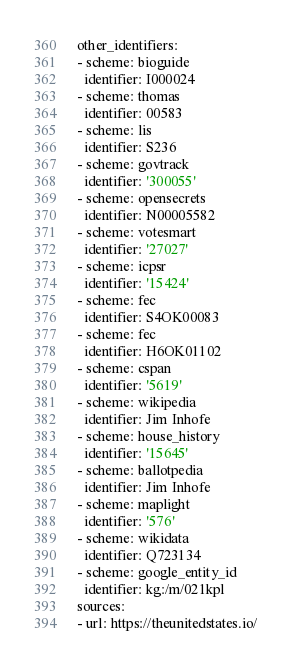<code> <loc_0><loc_0><loc_500><loc_500><_YAML_>other_identifiers:
- scheme: bioguide
  identifier: I000024
- scheme: thomas
  identifier: 00583
- scheme: lis
  identifier: S236
- scheme: govtrack
  identifier: '300055'
- scheme: opensecrets
  identifier: N00005582
- scheme: votesmart
  identifier: '27027'
- scheme: icpsr
  identifier: '15424'
- scheme: fec
  identifier: S4OK00083
- scheme: fec
  identifier: H6OK01102
- scheme: cspan
  identifier: '5619'
- scheme: wikipedia
  identifier: Jim Inhofe
- scheme: house_history
  identifier: '15645'
- scheme: ballotpedia
  identifier: Jim Inhofe
- scheme: maplight
  identifier: '576'
- scheme: wikidata
  identifier: Q723134
- scheme: google_entity_id
  identifier: kg:/m/021kpl
sources:
- url: https://theunitedstates.io/
</code> 